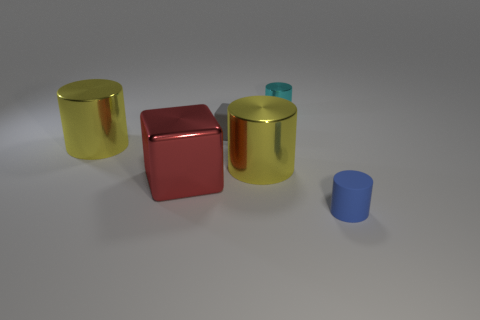Is there anything else that is made of the same material as the small cyan object?
Provide a succinct answer. Yes. The gray rubber object has what shape?
Keep it short and to the point. Cube. What is the shape of the other rubber object that is the same size as the blue thing?
Make the answer very short. Cube. Is there anything else of the same color as the rubber cube?
Keep it short and to the point. No. What size is the cyan cylinder that is the same material as the big red cube?
Ensure brevity in your answer.  Small. Does the gray matte object have the same shape as the matte thing that is on the right side of the cyan metal cylinder?
Provide a succinct answer. No. The gray cube has what size?
Give a very brief answer. Small. Are there fewer blue rubber cylinders that are in front of the tiny blue matte object than small red shiny things?
Your answer should be very brief. No. How many other objects are the same size as the cyan metallic thing?
Give a very brief answer. 2. Does the big thing right of the tiny rubber block have the same color as the large shiny object left of the big red shiny thing?
Give a very brief answer. Yes. 